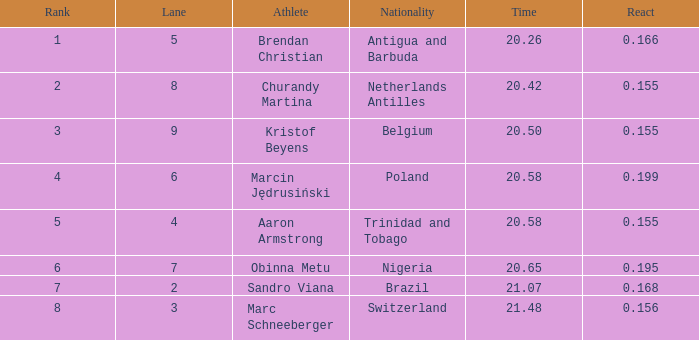Which Lane has a Time larger than 20.5, and a Nationality of trinidad and tobago? 4.0. 